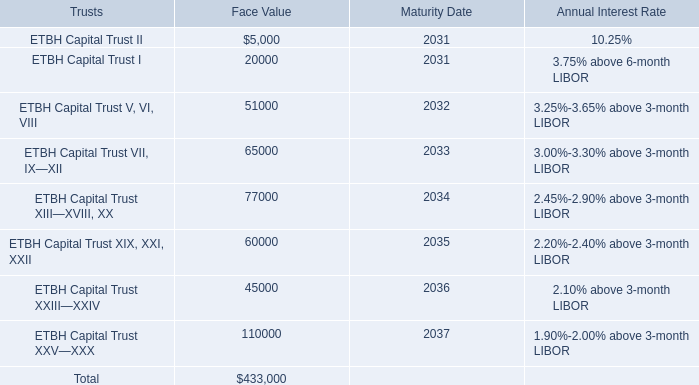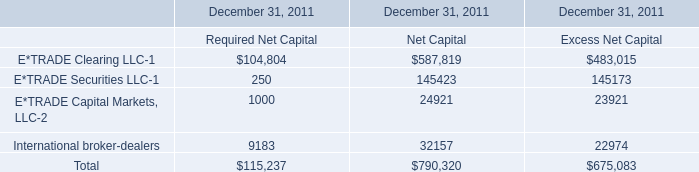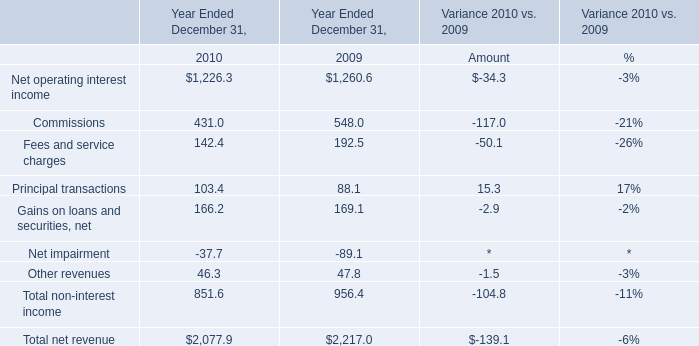What's the sum of ETBH Capital Trust V, VI, VIII of Face Value, Net operating interest income of Year Ended December 31, 2010, and ETBH Capital Trust XXV—XXX of Face Value ? 
Computations: ((51000.0 + 1226.3) + 110000.0)
Answer: 162226.3. 